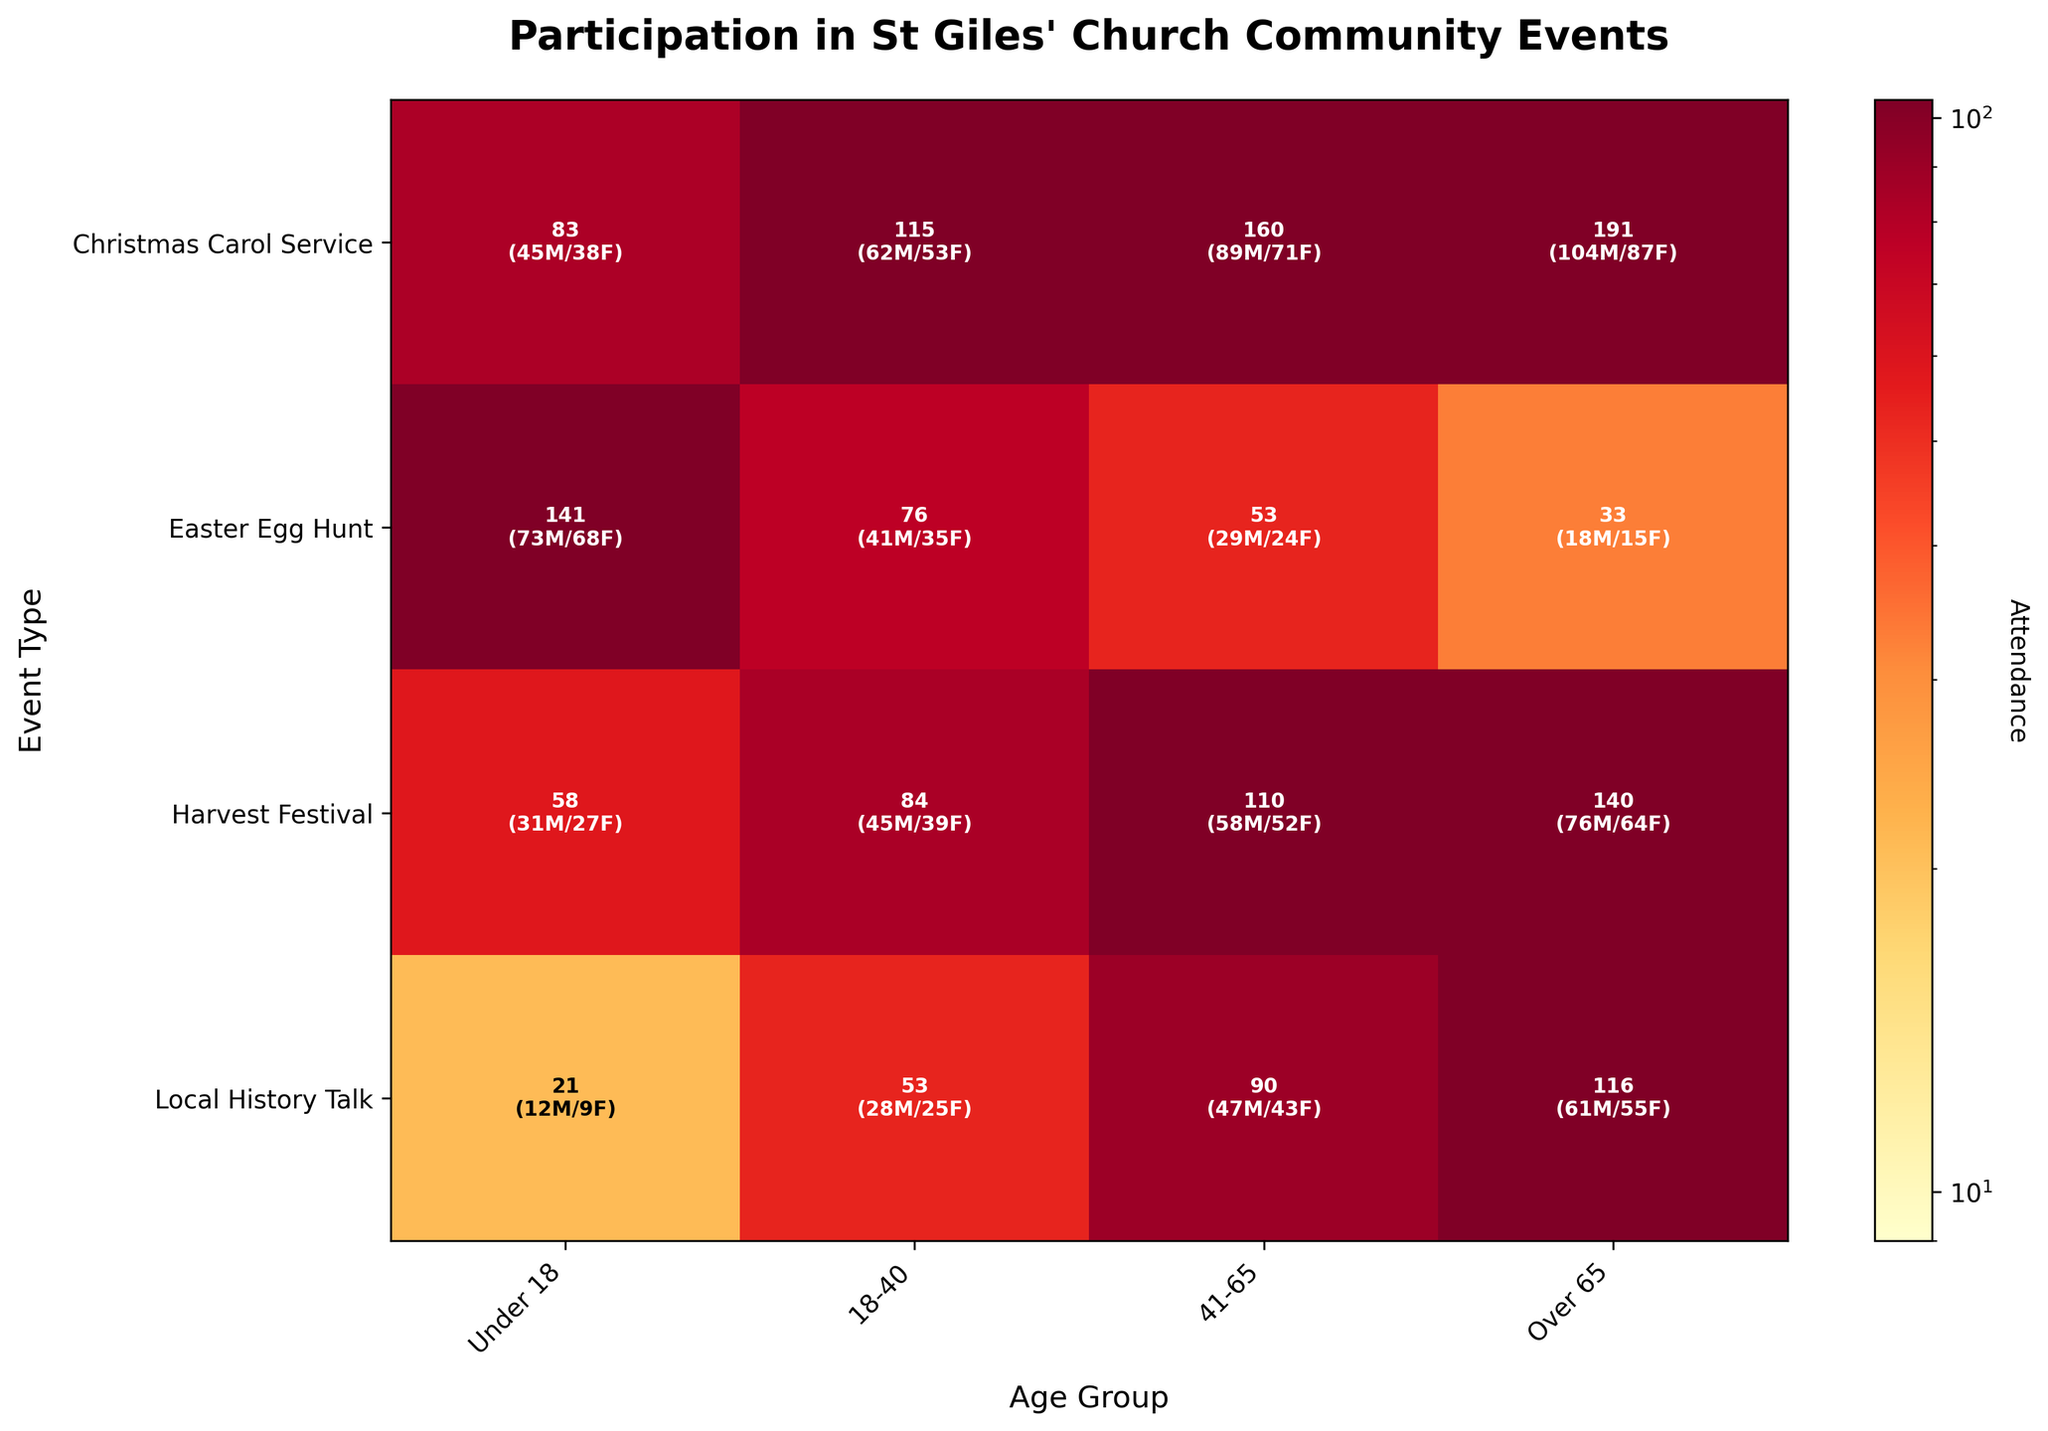Which event type had the highest overall attendance? To find the highest overall attendance, you sum up the values for males and females across all age groups for each event type. The Christmas Carol Service has the highest total attendance.
Answer: Christmas Carol Service What is the attendance difference between males and females for the Easter Egg Hunt? Look at the total male and female attendance values for the Easter Egg Hunt. The counts are 142 males and 161 females. The difference is 161 - 142.
Answer: 19 Which age group had the lowest female participation in the Harvest Festival? For the Harvest Festival, compare female attendance across different age groups. The 'Under 18' group has the lowest female participation with 31 attendees.
Answer: Under 18 How many males attended the Local History Talk in the '18-40' age group? Locate the data for Local History Talk and check the male attendance for the '18-40' age group, which is 25.
Answer: 25 Compare the attendance of females in the 'Over 65' group for Harvest Festival and Local History Talk. Which is higher? Compare the 'Over 65' female attendance values for Harvest Festival (76) and Local History Talk (61). Harvest Festival has a higher attendance.
Answer: Harvest Festival What is the total attendance for the under 18 age group across all events? Add the total attendance (male + female) for the 'Under 18' group across all events: 83 (Christmas Carol Service) + 141 (Easter Egg Hunt) + 58 (Harvest Festival) + 21 (Local History Talk). The sum is 303.
Answer: 303 Between the '18-40' and '41-65' age groups, which one had more overall attendance in the Christmas Carol Service? Sum the attendance for both age groups in the Christmas Carol Service: '18-40' (62 female + 53 male = 115) and '41-65' (89 female + 71 male = 160). The '41-65' group had higher attendance.
Answer: 41-65 How much greater is the attendance for the 'Over 65' age group compared to the 'Under 18' age group in the Local History Talk? Compare the attendance: 'Over 65' (116) and 'Under 18' (21) in the Local History Talk. The difference is 116 - 21.
Answer: 95 